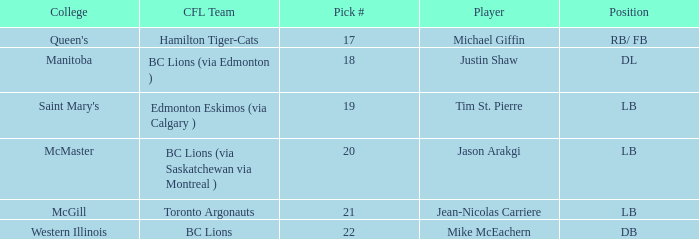How many cfl teams had pick # 21? 1.0. 